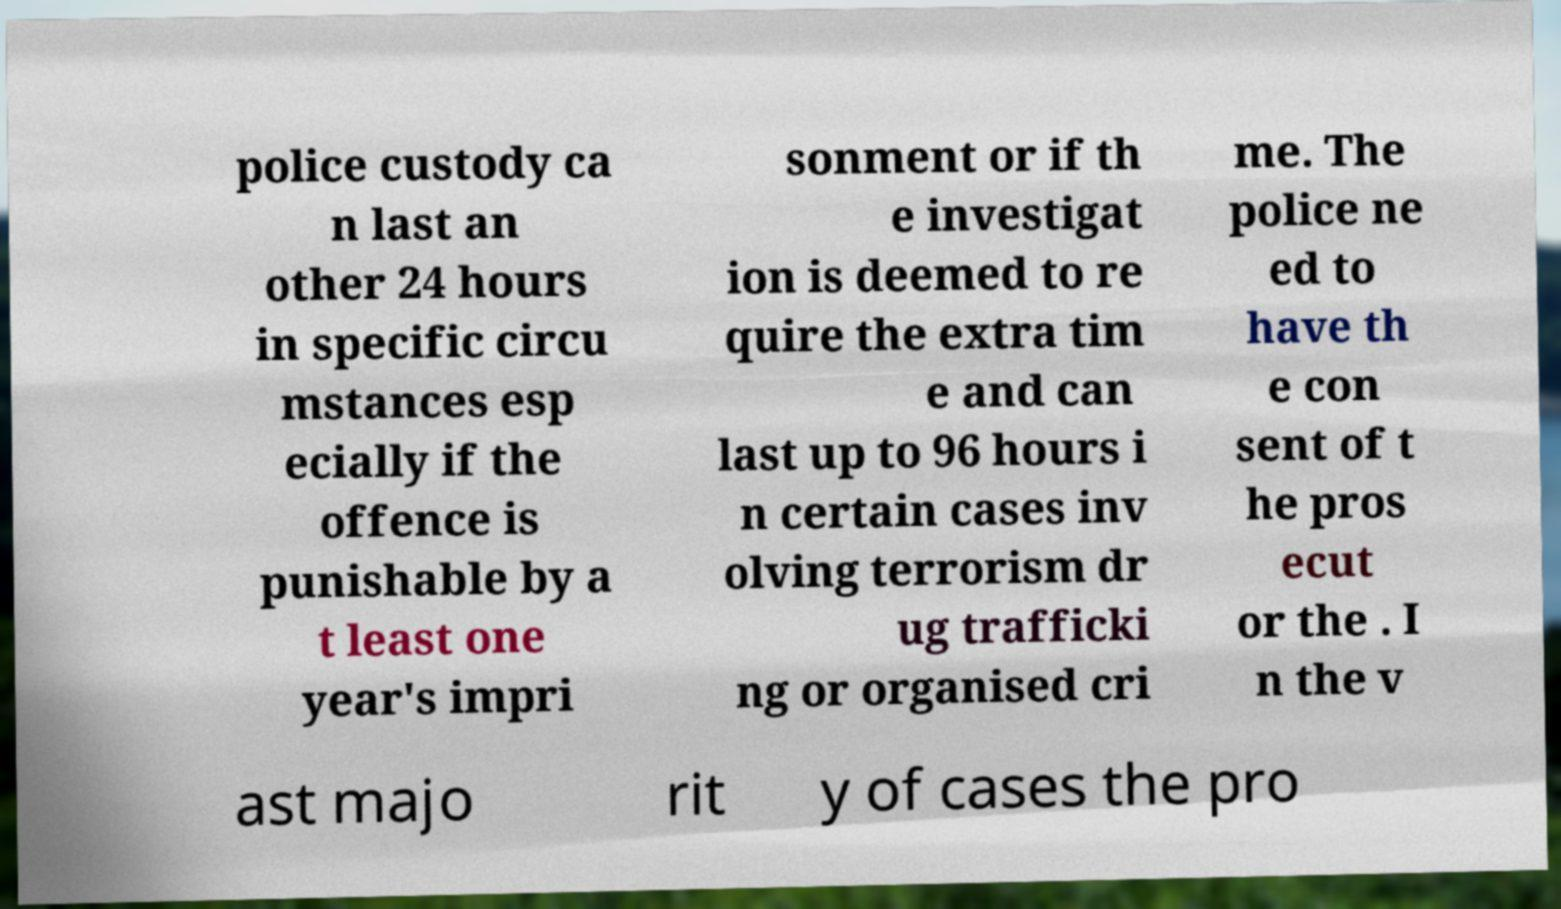Can you accurately transcribe the text from the provided image for me? police custody ca n last an other 24 hours in specific circu mstances esp ecially if the offence is punishable by a t least one year's impri sonment or if th e investigat ion is deemed to re quire the extra tim e and can last up to 96 hours i n certain cases inv olving terrorism dr ug trafficki ng or organised cri me. The police ne ed to have th e con sent of t he pros ecut or the . I n the v ast majo rit y of cases the pro 